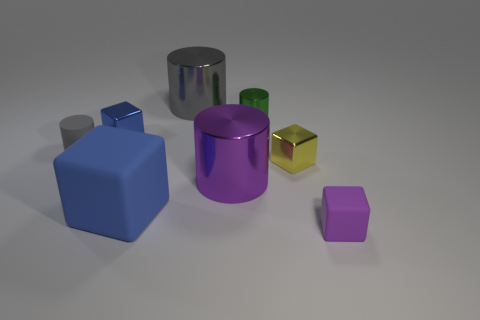Subtract all cyan blocks. How many gray cylinders are left? 2 Add 1 blue metallic blocks. How many objects exist? 9 Subtract all small rubber blocks. How many blocks are left? 3 Subtract 1 cylinders. How many cylinders are left? 3 Subtract all green cubes. Subtract all cyan cylinders. How many cubes are left? 4 Add 5 large brown balls. How many large brown balls exist? 5 Subtract 0 brown balls. How many objects are left? 8 Subtract all small yellow blocks. Subtract all cyan cubes. How many objects are left? 7 Add 6 tiny purple blocks. How many tiny purple blocks are left? 7 